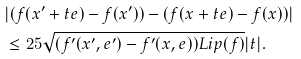Convert formula to latex. <formula><loc_0><loc_0><loc_500><loc_500>& | ( f ( x ^ { \prime } + t e ) - f ( x ^ { \prime } ) ) - ( f ( x + t e ) - f ( x ) ) | \\ & \leq 2 5 \sqrt { ( f ^ { \prime } ( x ^ { \prime } , e ^ { \prime } ) - f ^ { \prime } ( x , e ) ) L i p ( f ) } | t | .</formula> 